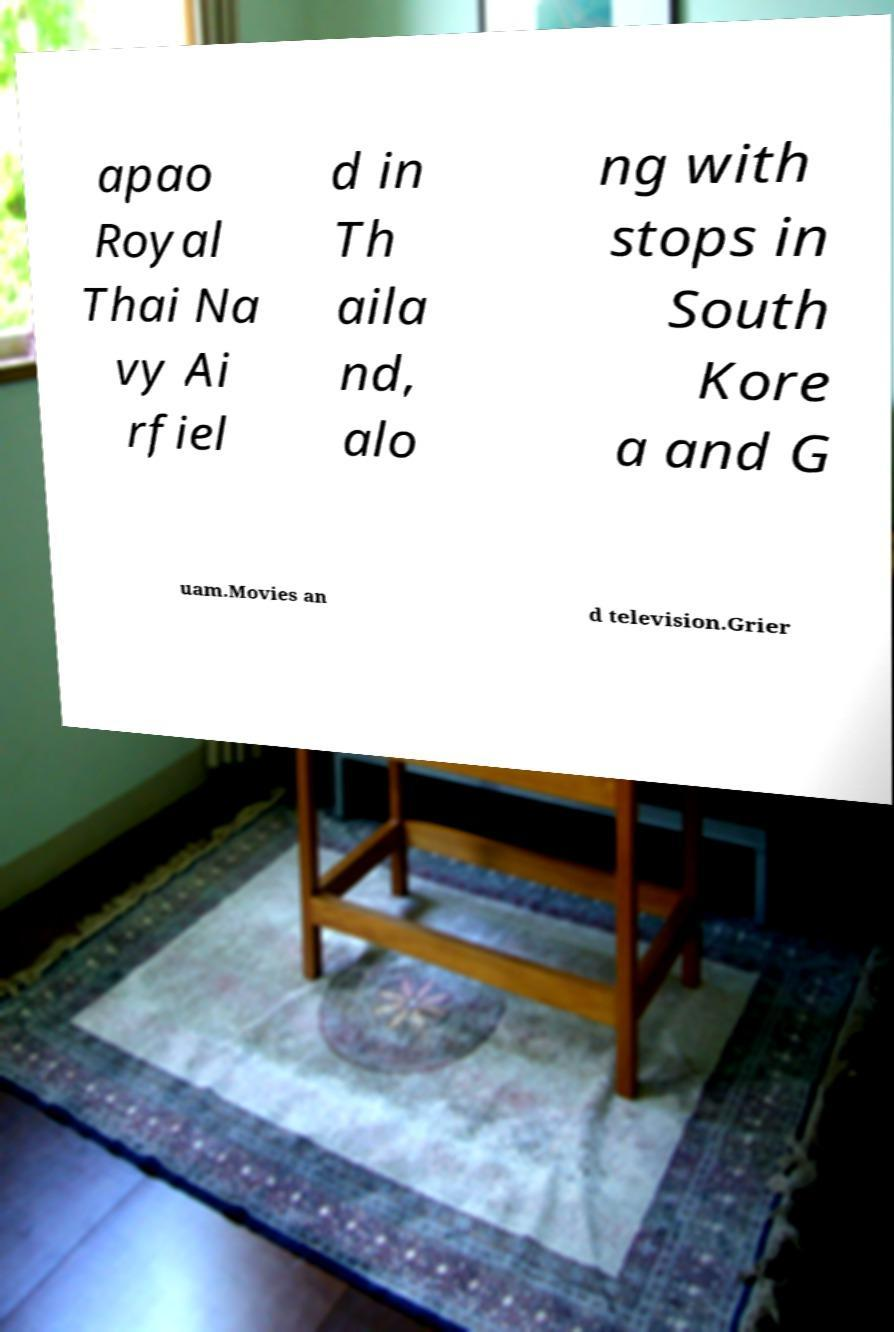I need the written content from this picture converted into text. Can you do that? apao Royal Thai Na vy Ai rfiel d in Th aila nd, alo ng with stops in South Kore a and G uam.Movies an d television.Grier 